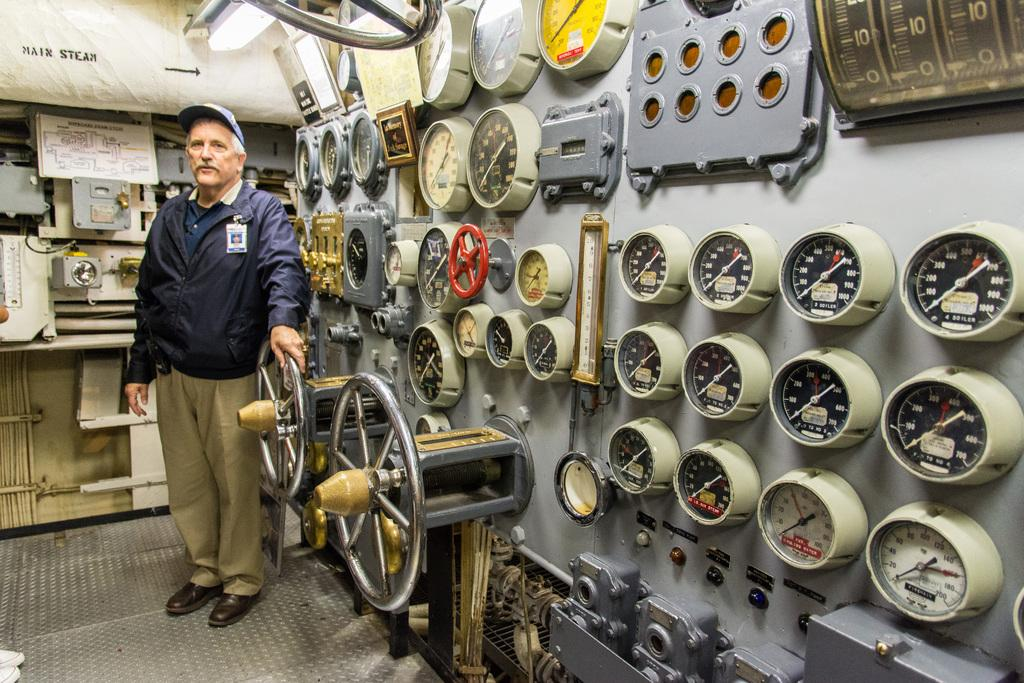Who is present in the image? There is a man in the image. What is the man wearing? The man is wearing a blue jacket. Where might the image have been taken? The image appears to be taken on a ship. What is visible beneath the man's feet? There is a floor visible in the image. What can be used to steer the ship? There is a steering wheel present in the image. Can you see any nests in the image? There are no nests present in the image. What type of farm animals can be seen on the ship in the image? There are no farm animals present in the image, as it is taken on a ship and not a farm. 